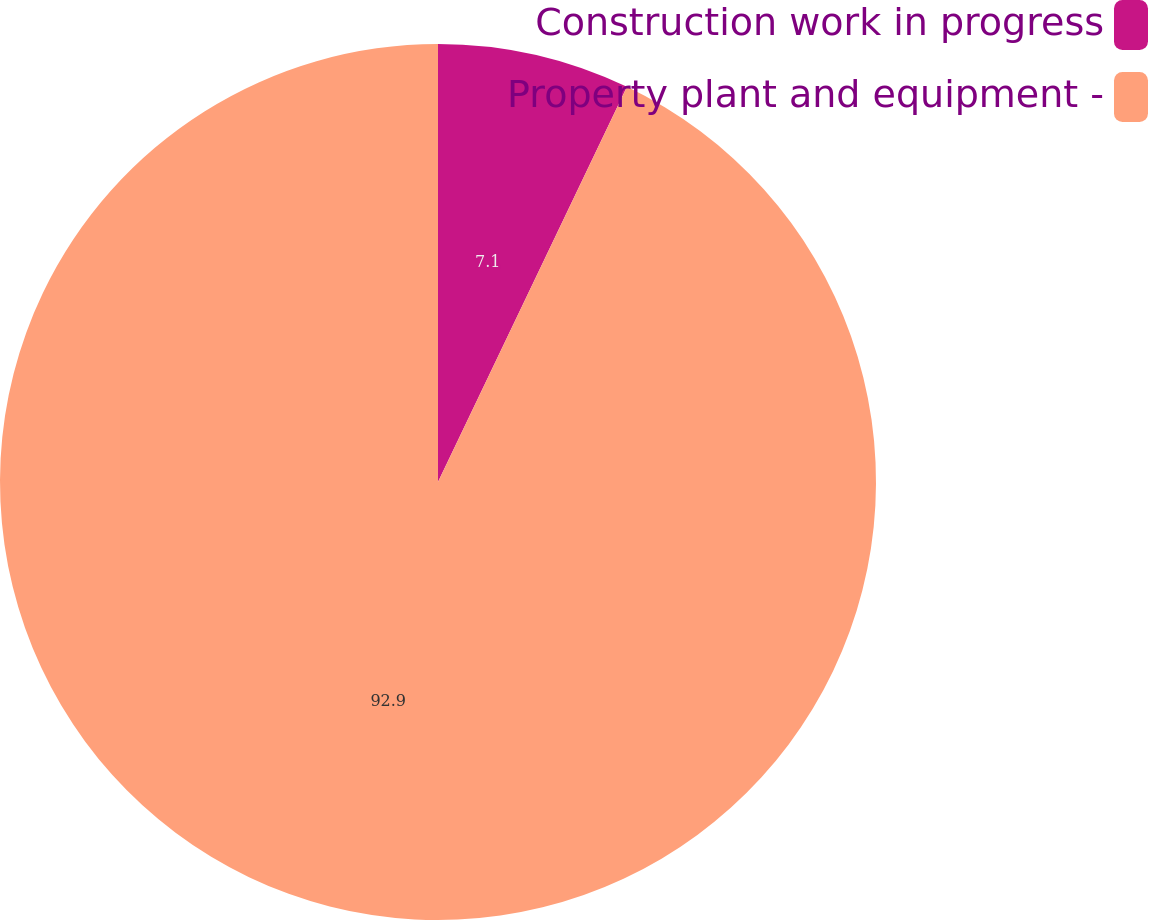<chart> <loc_0><loc_0><loc_500><loc_500><pie_chart><fcel>Construction work in progress<fcel>Property plant and equipment -<nl><fcel>7.1%<fcel>92.9%<nl></chart> 